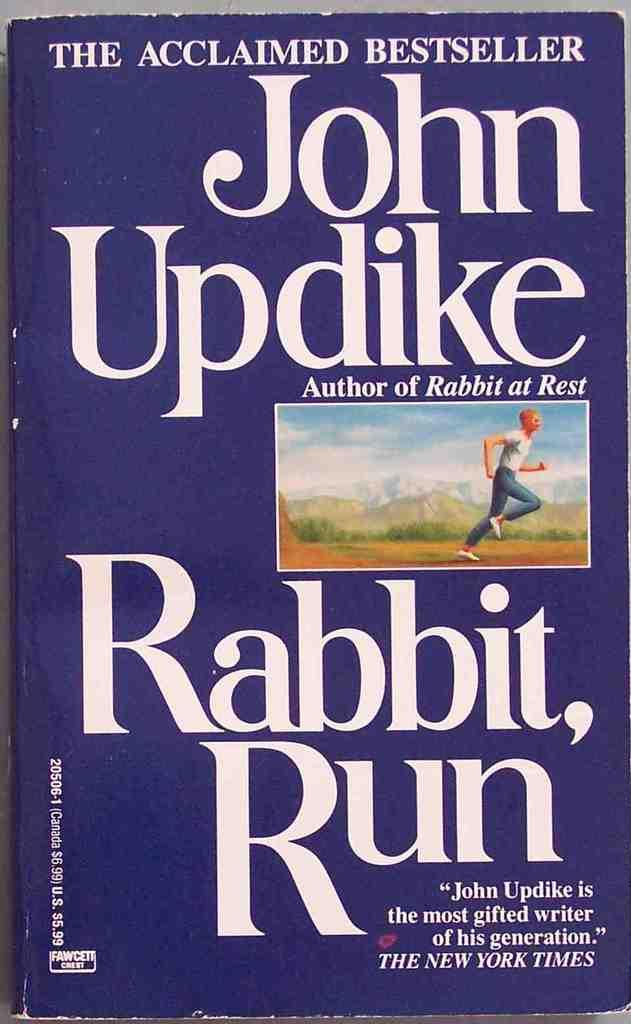Provide a one-sentence caption for the provided image. John Updike's Rabbit, Run is an acclaimed bestseller that was reviewed by The New York Times.. 